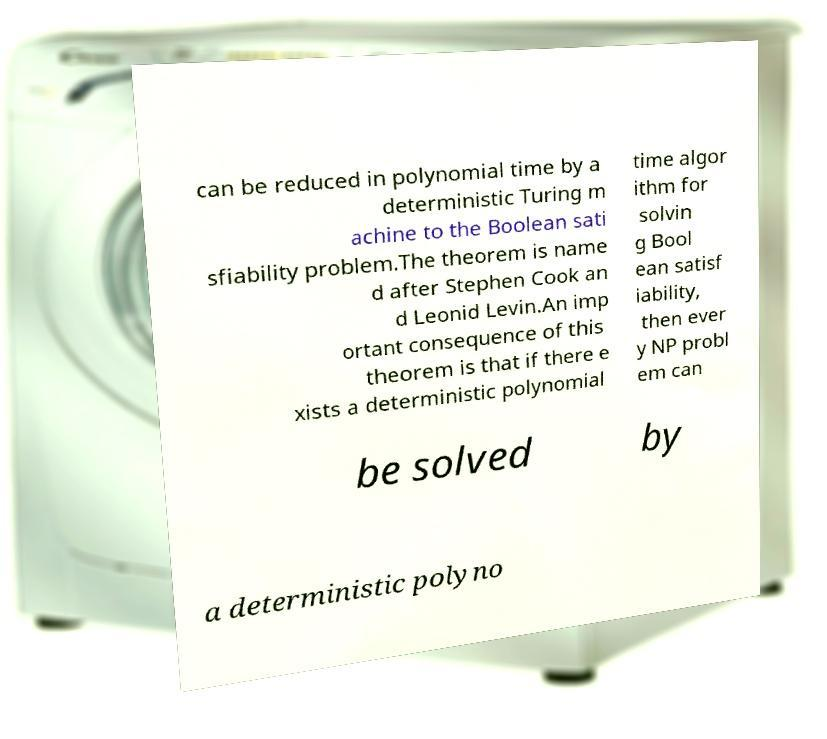Could you assist in decoding the text presented in this image and type it out clearly? can be reduced in polynomial time by a deterministic Turing m achine to the Boolean sati sfiability problem.The theorem is name d after Stephen Cook an d Leonid Levin.An imp ortant consequence of this theorem is that if there e xists a deterministic polynomial time algor ithm for solvin g Bool ean satisf iability, then ever y NP probl em can be solved by a deterministic polyno 